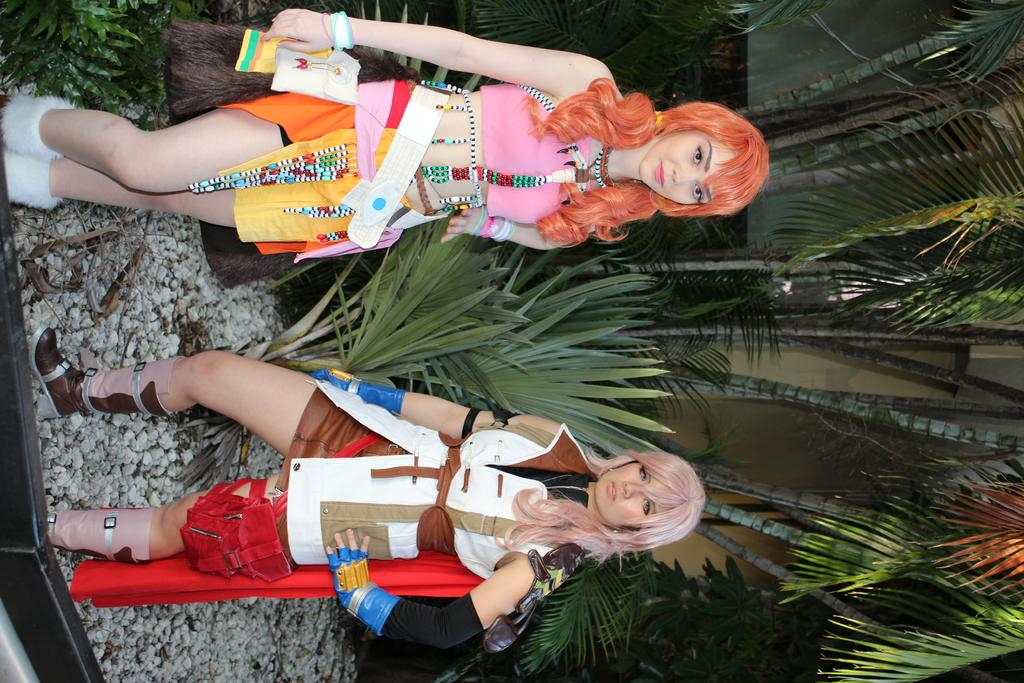How many women are in the image? There are two women standing in the image. What type of natural elements can be seen in the image? There are plants, trees, and rocks in the image. Can you describe any other objects present in the image? There are other objects present in the image, but their specific details are not mentioned in the provided facts. What type of alarm can be heard in the image? There is no alarm present in the image, as it is a still image and cannot produce sound. 